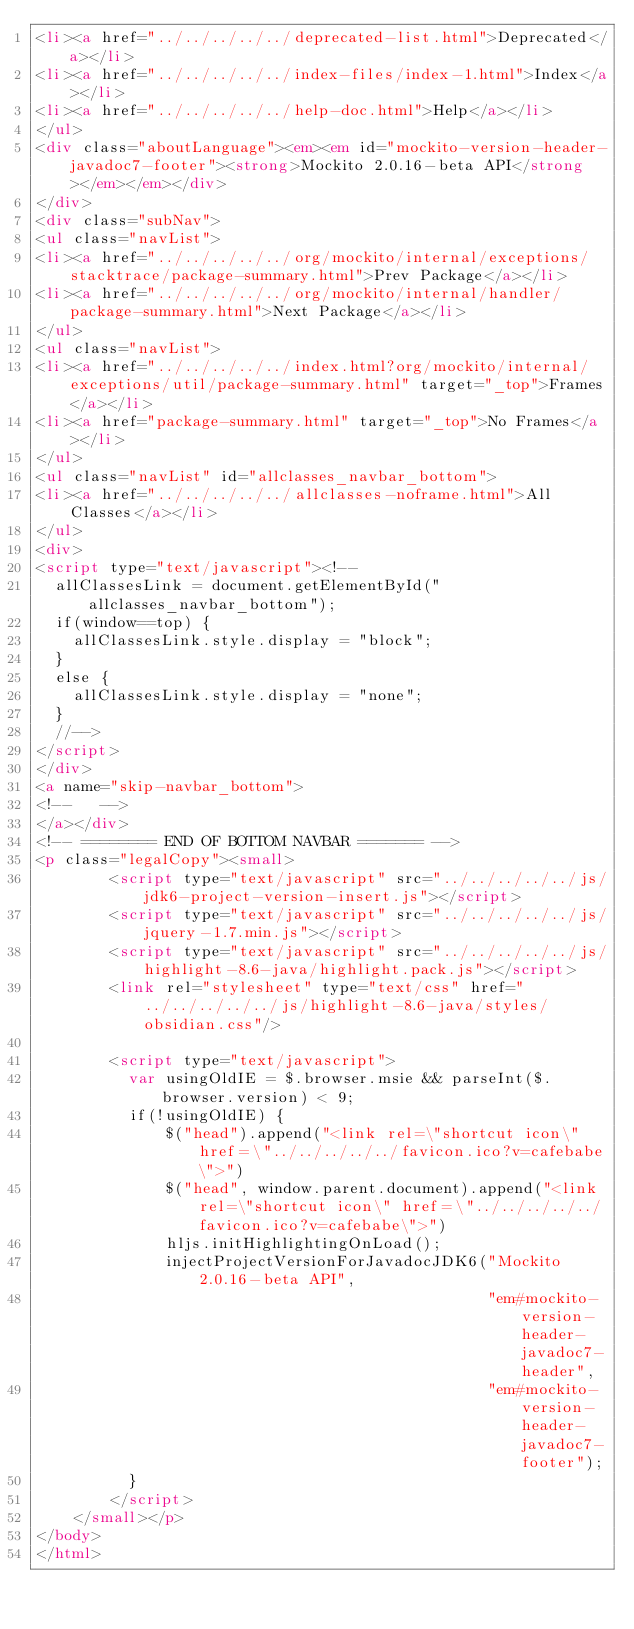<code> <loc_0><loc_0><loc_500><loc_500><_HTML_><li><a href="../../../../../deprecated-list.html">Deprecated</a></li>
<li><a href="../../../../../index-files/index-1.html">Index</a></li>
<li><a href="../../../../../help-doc.html">Help</a></li>
</ul>
<div class="aboutLanguage"><em><em id="mockito-version-header-javadoc7-footer"><strong>Mockito 2.0.16-beta API</strong></em></em></div>
</div>
<div class="subNav">
<ul class="navList">
<li><a href="../../../../../org/mockito/internal/exceptions/stacktrace/package-summary.html">Prev Package</a></li>
<li><a href="../../../../../org/mockito/internal/handler/package-summary.html">Next Package</a></li>
</ul>
<ul class="navList">
<li><a href="../../../../../index.html?org/mockito/internal/exceptions/util/package-summary.html" target="_top">Frames</a></li>
<li><a href="package-summary.html" target="_top">No Frames</a></li>
</ul>
<ul class="navList" id="allclasses_navbar_bottom">
<li><a href="../../../../../allclasses-noframe.html">All Classes</a></li>
</ul>
<div>
<script type="text/javascript"><!--
  allClassesLink = document.getElementById("allclasses_navbar_bottom");
  if(window==top) {
    allClassesLink.style.display = "block";
  }
  else {
    allClassesLink.style.display = "none";
  }
  //-->
</script>
</div>
<a name="skip-navbar_bottom">
<!--   -->
</a></div>
<!-- ======== END OF BOTTOM NAVBAR ======= -->
<p class="legalCopy"><small>
        <script type="text/javascript" src="../../../../../js/jdk6-project-version-insert.js"></script>
        <script type="text/javascript" src="../../../../../js/jquery-1.7.min.js"></script>
        <script type="text/javascript" src="../../../../../js/highlight-8.6-java/highlight.pack.js"></script>
        <link rel="stylesheet" type="text/css" href="../../../../../js/highlight-8.6-java/styles/obsidian.css"/>

        <script type="text/javascript">
          var usingOldIE = $.browser.msie && parseInt($.browser.version) < 9;
          if(!usingOldIE) {
              $("head").append("<link rel=\"shortcut icon\" href=\"../../../../../favicon.ico?v=cafebabe\">")
              $("head", window.parent.document).append("<link rel=\"shortcut icon\" href=\"../../../../../favicon.ico?v=cafebabe\">")
              hljs.initHighlightingOnLoad();
              injectProjectVersionForJavadocJDK6("Mockito 2.0.16-beta API",
                                                 "em#mockito-version-header-javadoc7-header",
                                                 "em#mockito-version-header-javadoc7-footer");
          }
        </script>
    </small></p>
</body>
</html>
</code> 